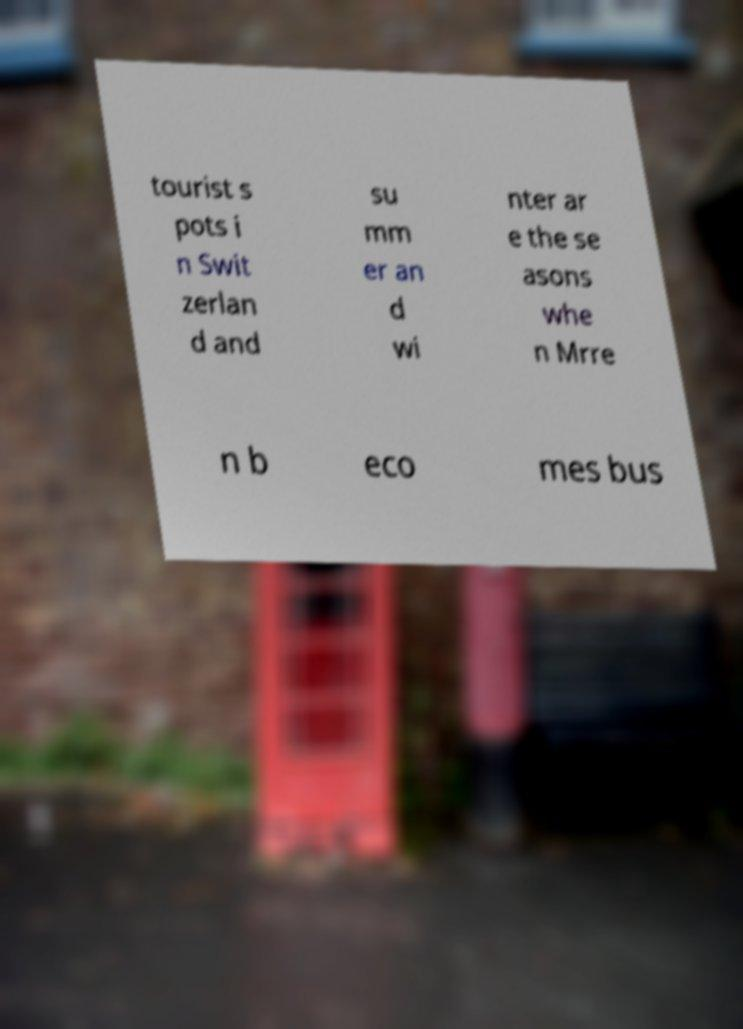For documentation purposes, I need the text within this image transcribed. Could you provide that? tourist s pots i n Swit zerlan d and su mm er an d wi nter ar e the se asons whe n Mrre n b eco mes bus 